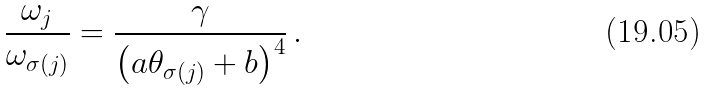Convert formula to latex. <formula><loc_0><loc_0><loc_500><loc_500>\frac { \omega _ { j } } { \omega _ { \sigma ( j ) } } = \frac { \gamma } { \left ( a \theta _ { \sigma ( j ) } + b \right ) ^ { 4 } } \, .</formula> 